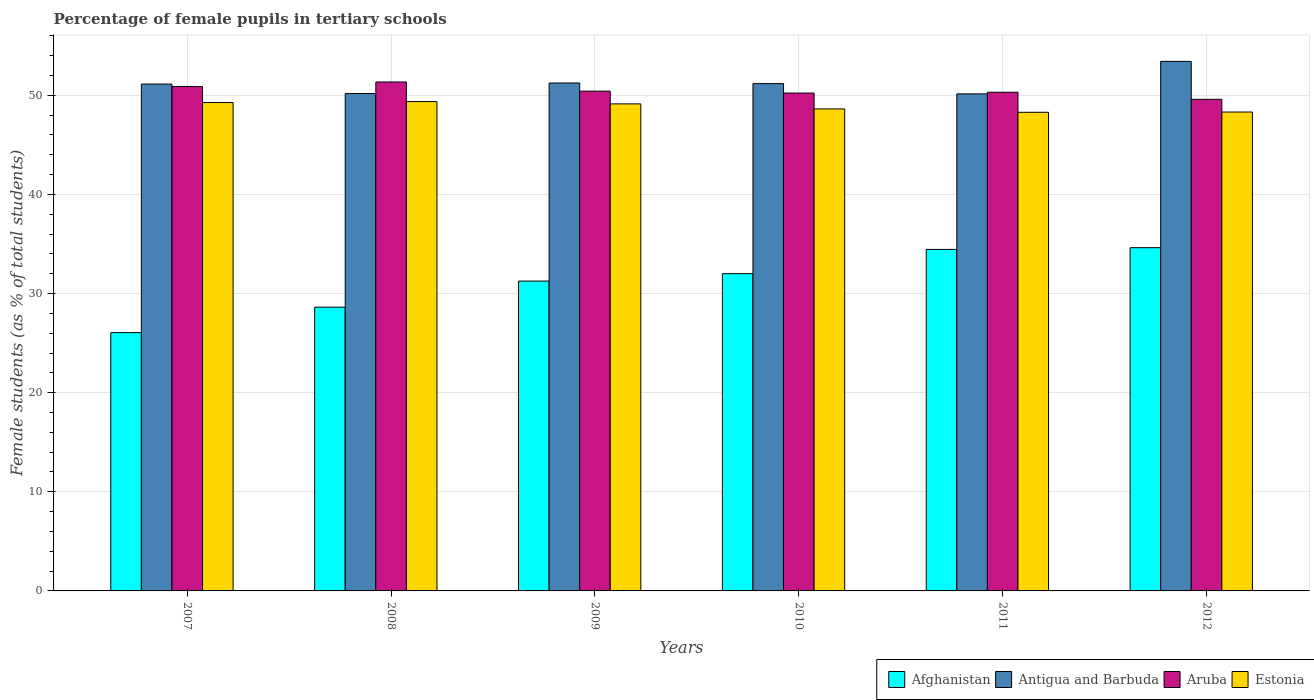How many groups of bars are there?
Offer a very short reply. 6. Are the number of bars per tick equal to the number of legend labels?
Ensure brevity in your answer.  Yes. How many bars are there on the 1st tick from the left?
Keep it short and to the point. 4. What is the percentage of female pupils in tertiary schools in Afghanistan in 2010?
Ensure brevity in your answer.  32.01. Across all years, what is the maximum percentage of female pupils in tertiary schools in Estonia?
Offer a terse response. 49.37. Across all years, what is the minimum percentage of female pupils in tertiary schools in Antigua and Barbuda?
Your answer should be compact. 50.15. In which year was the percentage of female pupils in tertiary schools in Aruba maximum?
Provide a succinct answer. 2008. What is the total percentage of female pupils in tertiary schools in Estonia in the graph?
Make the answer very short. 293.02. What is the difference between the percentage of female pupils in tertiary schools in Estonia in 2009 and that in 2012?
Offer a very short reply. 0.82. What is the difference between the percentage of female pupils in tertiary schools in Aruba in 2008 and the percentage of female pupils in tertiary schools in Afghanistan in 2012?
Provide a short and direct response. 16.72. What is the average percentage of female pupils in tertiary schools in Aruba per year?
Provide a succinct answer. 50.47. In the year 2011, what is the difference between the percentage of female pupils in tertiary schools in Antigua and Barbuda and percentage of female pupils in tertiary schools in Estonia?
Make the answer very short. 1.86. In how many years, is the percentage of female pupils in tertiary schools in Antigua and Barbuda greater than 40 %?
Your response must be concise. 6. What is the ratio of the percentage of female pupils in tertiary schools in Afghanistan in 2008 to that in 2011?
Your answer should be very brief. 0.83. Is the percentage of female pupils in tertiary schools in Antigua and Barbuda in 2007 less than that in 2012?
Offer a terse response. Yes. What is the difference between the highest and the second highest percentage of female pupils in tertiary schools in Estonia?
Provide a short and direct response. 0.1. What is the difference between the highest and the lowest percentage of female pupils in tertiary schools in Estonia?
Give a very brief answer. 1.08. Is the sum of the percentage of female pupils in tertiary schools in Estonia in 2009 and 2010 greater than the maximum percentage of female pupils in tertiary schools in Antigua and Barbuda across all years?
Your answer should be compact. Yes. What does the 4th bar from the left in 2009 represents?
Keep it short and to the point. Estonia. What does the 2nd bar from the right in 2010 represents?
Your response must be concise. Aruba. Is it the case that in every year, the sum of the percentage of female pupils in tertiary schools in Estonia and percentage of female pupils in tertiary schools in Antigua and Barbuda is greater than the percentage of female pupils in tertiary schools in Aruba?
Provide a succinct answer. Yes. How many years are there in the graph?
Your response must be concise. 6. What is the difference between two consecutive major ticks on the Y-axis?
Keep it short and to the point. 10. Does the graph contain any zero values?
Provide a short and direct response. No. Where does the legend appear in the graph?
Provide a short and direct response. Bottom right. What is the title of the graph?
Your answer should be compact. Percentage of female pupils in tertiary schools. What is the label or title of the Y-axis?
Ensure brevity in your answer.  Female students (as % of total students). What is the Female students (as % of total students) of Afghanistan in 2007?
Give a very brief answer. 26.06. What is the Female students (as % of total students) in Antigua and Barbuda in 2007?
Give a very brief answer. 51.14. What is the Female students (as % of total students) in Aruba in 2007?
Offer a very short reply. 50.89. What is the Female students (as % of total students) of Estonia in 2007?
Offer a terse response. 49.27. What is the Female students (as % of total students) of Afghanistan in 2008?
Give a very brief answer. 28.63. What is the Female students (as % of total students) in Antigua and Barbuda in 2008?
Your response must be concise. 50.19. What is the Female students (as % of total students) of Aruba in 2008?
Keep it short and to the point. 51.35. What is the Female students (as % of total students) of Estonia in 2008?
Provide a short and direct response. 49.37. What is the Female students (as % of total students) of Afghanistan in 2009?
Offer a terse response. 31.26. What is the Female students (as % of total students) in Antigua and Barbuda in 2009?
Ensure brevity in your answer.  51.24. What is the Female students (as % of total students) in Aruba in 2009?
Give a very brief answer. 50.42. What is the Female students (as % of total students) of Estonia in 2009?
Give a very brief answer. 49.14. What is the Female students (as % of total students) in Afghanistan in 2010?
Provide a short and direct response. 32.01. What is the Female students (as % of total students) of Antigua and Barbuda in 2010?
Ensure brevity in your answer.  51.19. What is the Female students (as % of total students) of Aruba in 2010?
Ensure brevity in your answer.  50.23. What is the Female students (as % of total students) of Estonia in 2010?
Provide a short and direct response. 48.63. What is the Female students (as % of total students) in Afghanistan in 2011?
Ensure brevity in your answer.  34.46. What is the Female students (as % of total students) of Antigua and Barbuda in 2011?
Your answer should be very brief. 50.15. What is the Female students (as % of total students) of Aruba in 2011?
Offer a terse response. 50.31. What is the Female students (as % of total students) of Estonia in 2011?
Ensure brevity in your answer.  48.29. What is the Female students (as % of total students) of Afghanistan in 2012?
Offer a very short reply. 34.63. What is the Female students (as % of total students) in Antigua and Barbuda in 2012?
Offer a very short reply. 53.43. What is the Female students (as % of total students) of Aruba in 2012?
Provide a succinct answer. 49.6. What is the Female students (as % of total students) in Estonia in 2012?
Your answer should be very brief. 48.32. Across all years, what is the maximum Female students (as % of total students) of Afghanistan?
Make the answer very short. 34.63. Across all years, what is the maximum Female students (as % of total students) in Antigua and Barbuda?
Make the answer very short. 53.43. Across all years, what is the maximum Female students (as % of total students) in Aruba?
Your answer should be compact. 51.35. Across all years, what is the maximum Female students (as % of total students) in Estonia?
Your response must be concise. 49.37. Across all years, what is the minimum Female students (as % of total students) of Afghanistan?
Your answer should be compact. 26.06. Across all years, what is the minimum Female students (as % of total students) in Antigua and Barbuda?
Your answer should be compact. 50.15. Across all years, what is the minimum Female students (as % of total students) in Aruba?
Offer a very short reply. 49.6. Across all years, what is the minimum Female students (as % of total students) in Estonia?
Keep it short and to the point. 48.29. What is the total Female students (as % of total students) in Afghanistan in the graph?
Make the answer very short. 187.05. What is the total Female students (as % of total students) of Antigua and Barbuda in the graph?
Make the answer very short. 307.33. What is the total Female students (as % of total students) in Aruba in the graph?
Your answer should be compact. 302.8. What is the total Female students (as % of total students) in Estonia in the graph?
Provide a succinct answer. 293.02. What is the difference between the Female students (as % of total students) of Afghanistan in 2007 and that in 2008?
Offer a very short reply. -2.57. What is the difference between the Female students (as % of total students) in Antigua and Barbuda in 2007 and that in 2008?
Give a very brief answer. 0.95. What is the difference between the Female students (as % of total students) in Aruba in 2007 and that in 2008?
Offer a very short reply. -0.46. What is the difference between the Female students (as % of total students) in Estonia in 2007 and that in 2008?
Your answer should be compact. -0.1. What is the difference between the Female students (as % of total students) of Afghanistan in 2007 and that in 2009?
Give a very brief answer. -5.2. What is the difference between the Female students (as % of total students) in Antigua and Barbuda in 2007 and that in 2009?
Your response must be concise. -0.11. What is the difference between the Female students (as % of total students) in Aruba in 2007 and that in 2009?
Your response must be concise. 0.46. What is the difference between the Female students (as % of total students) in Estonia in 2007 and that in 2009?
Keep it short and to the point. 0.14. What is the difference between the Female students (as % of total students) in Afghanistan in 2007 and that in 2010?
Your answer should be very brief. -5.95. What is the difference between the Female students (as % of total students) in Antigua and Barbuda in 2007 and that in 2010?
Ensure brevity in your answer.  -0.05. What is the difference between the Female students (as % of total students) of Aruba in 2007 and that in 2010?
Offer a terse response. 0.65. What is the difference between the Female students (as % of total students) in Estonia in 2007 and that in 2010?
Your answer should be very brief. 0.64. What is the difference between the Female students (as % of total students) in Afghanistan in 2007 and that in 2011?
Provide a short and direct response. -8.39. What is the difference between the Female students (as % of total students) in Antigua and Barbuda in 2007 and that in 2011?
Keep it short and to the point. 0.99. What is the difference between the Female students (as % of total students) in Aruba in 2007 and that in 2011?
Your answer should be very brief. 0.57. What is the difference between the Female students (as % of total students) in Estonia in 2007 and that in 2011?
Provide a succinct answer. 0.98. What is the difference between the Female students (as % of total students) in Afghanistan in 2007 and that in 2012?
Your response must be concise. -8.57. What is the difference between the Female students (as % of total students) of Antigua and Barbuda in 2007 and that in 2012?
Make the answer very short. -2.29. What is the difference between the Female students (as % of total students) of Aruba in 2007 and that in 2012?
Your answer should be compact. 1.28. What is the difference between the Female students (as % of total students) of Estonia in 2007 and that in 2012?
Provide a succinct answer. 0.96. What is the difference between the Female students (as % of total students) of Afghanistan in 2008 and that in 2009?
Your answer should be very brief. -2.63. What is the difference between the Female students (as % of total students) of Antigua and Barbuda in 2008 and that in 2009?
Provide a succinct answer. -1.06. What is the difference between the Female students (as % of total students) of Aruba in 2008 and that in 2009?
Your response must be concise. 0.92. What is the difference between the Female students (as % of total students) of Estonia in 2008 and that in 2009?
Your response must be concise. 0.23. What is the difference between the Female students (as % of total students) of Afghanistan in 2008 and that in 2010?
Offer a very short reply. -3.38. What is the difference between the Female students (as % of total students) of Aruba in 2008 and that in 2010?
Provide a short and direct response. 1.12. What is the difference between the Female students (as % of total students) in Estonia in 2008 and that in 2010?
Offer a terse response. 0.74. What is the difference between the Female students (as % of total students) in Afghanistan in 2008 and that in 2011?
Give a very brief answer. -5.83. What is the difference between the Female students (as % of total students) in Antigua and Barbuda in 2008 and that in 2011?
Make the answer very short. 0.04. What is the difference between the Female students (as % of total students) of Aruba in 2008 and that in 2011?
Provide a short and direct response. 1.04. What is the difference between the Female students (as % of total students) in Estonia in 2008 and that in 2011?
Your answer should be compact. 1.08. What is the difference between the Female students (as % of total students) in Afghanistan in 2008 and that in 2012?
Make the answer very short. -6. What is the difference between the Female students (as % of total students) in Antigua and Barbuda in 2008 and that in 2012?
Ensure brevity in your answer.  -3.24. What is the difference between the Female students (as % of total students) of Aruba in 2008 and that in 2012?
Provide a short and direct response. 1.75. What is the difference between the Female students (as % of total students) of Estonia in 2008 and that in 2012?
Ensure brevity in your answer.  1.05. What is the difference between the Female students (as % of total students) in Afghanistan in 2009 and that in 2010?
Offer a very short reply. -0.75. What is the difference between the Female students (as % of total students) in Antigua and Barbuda in 2009 and that in 2010?
Your answer should be compact. 0.06. What is the difference between the Female students (as % of total students) of Aruba in 2009 and that in 2010?
Provide a short and direct response. 0.19. What is the difference between the Female students (as % of total students) of Estonia in 2009 and that in 2010?
Your answer should be very brief. 0.51. What is the difference between the Female students (as % of total students) in Afghanistan in 2009 and that in 2011?
Offer a terse response. -3.2. What is the difference between the Female students (as % of total students) in Antigua and Barbuda in 2009 and that in 2011?
Make the answer very short. 1.1. What is the difference between the Female students (as % of total students) in Aruba in 2009 and that in 2011?
Offer a terse response. 0.11. What is the difference between the Female students (as % of total students) in Estonia in 2009 and that in 2011?
Provide a succinct answer. 0.85. What is the difference between the Female students (as % of total students) in Afghanistan in 2009 and that in 2012?
Keep it short and to the point. -3.37. What is the difference between the Female students (as % of total students) in Antigua and Barbuda in 2009 and that in 2012?
Offer a terse response. -2.19. What is the difference between the Female students (as % of total students) in Aruba in 2009 and that in 2012?
Offer a very short reply. 0.82. What is the difference between the Female students (as % of total students) of Estonia in 2009 and that in 2012?
Offer a terse response. 0.82. What is the difference between the Female students (as % of total students) of Afghanistan in 2010 and that in 2011?
Give a very brief answer. -2.45. What is the difference between the Female students (as % of total students) in Antigua and Barbuda in 2010 and that in 2011?
Ensure brevity in your answer.  1.04. What is the difference between the Female students (as % of total students) in Aruba in 2010 and that in 2011?
Your response must be concise. -0.08. What is the difference between the Female students (as % of total students) of Estonia in 2010 and that in 2011?
Provide a short and direct response. 0.34. What is the difference between the Female students (as % of total students) in Afghanistan in 2010 and that in 2012?
Ensure brevity in your answer.  -2.62. What is the difference between the Female students (as % of total students) of Antigua and Barbuda in 2010 and that in 2012?
Keep it short and to the point. -2.24. What is the difference between the Female students (as % of total students) in Aruba in 2010 and that in 2012?
Offer a terse response. 0.63. What is the difference between the Female students (as % of total students) in Estonia in 2010 and that in 2012?
Ensure brevity in your answer.  0.31. What is the difference between the Female students (as % of total students) of Afghanistan in 2011 and that in 2012?
Your answer should be very brief. -0.17. What is the difference between the Female students (as % of total students) in Antigua and Barbuda in 2011 and that in 2012?
Provide a succinct answer. -3.28. What is the difference between the Female students (as % of total students) in Aruba in 2011 and that in 2012?
Your answer should be compact. 0.71. What is the difference between the Female students (as % of total students) in Estonia in 2011 and that in 2012?
Provide a short and direct response. -0.03. What is the difference between the Female students (as % of total students) of Afghanistan in 2007 and the Female students (as % of total students) of Antigua and Barbuda in 2008?
Ensure brevity in your answer.  -24.12. What is the difference between the Female students (as % of total students) in Afghanistan in 2007 and the Female students (as % of total students) in Aruba in 2008?
Give a very brief answer. -25.29. What is the difference between the Female students (as % of total students) in Afghanistan in 2007 and the Female students (as % of total students) in Estonia in 2008?
Give a very brief answer. -23.31. What is the difference between the Female students (as % of total students) of Antigua and Barbuda in 2007 and the Female students (as % of total students) of Aruba in 2008?
Make the answer very short. -0.21. What is the difference between the Female students (as % of total students) of Antigua and Barbuda in 2007 and the Female students (as % of total students) of Estonia in 2008?
Your response must be concise. 1.76. What is the difference between the Female students (as % of total students) in Aruba in 2007 and the Female students (as % of total students) in Estonia in 2008?
Provide a succinct answer. 1.51. What is the difference between the Female students (as % of total students) in Afghanistan in 2007 and the Female students (as % of total students) in Antigua and Barbuda in 2009?
Offer a terse response. -25.18. What is the difference between the Female students (as % of total students) in Afghanistan in 2007 and the Female students (as % of total students) in Aruba in 2009?
Make the answer very short. -24.36. What is the difference between the Female students (as % of total students) in Afghanistan in 2007 and the Female students (as % of total students) in Estonia in 2009?
Keep it short and to the point. -23.08. What is the difference between the Female students (as % of total students) in Antigua and Barbuda in 2007 and the Female students (as % of total students) in Aruba in 2009?
Offer a terse response. 0.71. What is the difference between the Female students (as % of total students) in Antigua and Barbuda in 2007 and the Female students (as % of total students) in Estonia in 2009?
Offer a terse response. 2. What is the difference between the Female students (as % of total students) of Aruba in 2007 and the Female students (as % of total students) of Estonia in 2009?
Your response must be concise. 1.75. What is the difference between the Female students (as % of total students) of Afghanistan in 2007 and the Female students (as % of total students) of Antigua and Barbuda in 2010?
Your response must be concise. -25.12. What is the difference between the Female students (as % of total students) of Afghanistan in 2007 and the Female students (as % of total students) of Aruba in 2010?
Your answer should be compact. -24.17. What is the difference between the Female students (as % of total students) of Afghanistan in 2007 and the Female students (as % of total students) of Estonia in 2010?
Your answer should be very brief. -22.57. What is the difference between the Female students (as % of total students) in Antigua and Barbuda in 2007 and the Female students (as % of total students) in Aruba in 2010?
Your answer should be compact. 0.9. What is the difference between the Female students (as % of total students) in Antigua and Barbuda in 2007 and the Female students (as % of total students) in Estonia in 2010?
Provide a succinct answer. 2.51. What is the difference between the Female students (as % of total students) in Aruba in 2007 and the Female students (as % of total students) in Estonia in 2010?
Offer a very short reply. 2.26. What is the difference between the Female students (as % of total students) in Afghanistan in 2007 and the Female students (as % of total students) in Antigua and Barbuda in 2011?
Your answer should be very brief. -24.09. What is the difference between the Female students (as % of total students) of Afghanistan in 2007 and the Female students (as % of total students) of Aruba in 2011?
Offer a very short reply. -24.25. What is the difference between the Female students (as % of total students) of Afghanistan in 2007 and the Female students (as % of total students) of Estonia in 2011?
Give a very brief answer. -22.23. What is the difference between the Female students (as % of total students) in Antigua and Barbuda in 2007 and the Female students (as % of total students) in Aruba in 2011?
Give a very brief answer. 0.82. What is the difference between the Female students (as % of total students) in Antigua and Barbuda in 2007 and the Female students (as % of total students) in Estonia in 2011?
Ensure brevity in your answer.  2.84. What is the difference between the Female students (as % of total students) of Aruba in 2007 and the Female students (as % of total students) of Estonia in 2011?
Your answer should be compact. 2.59. What is the difference between the Female students (as % of total students) of Afghanistan in 2007 and the Female students (as % of total students) of Antigua and Barbuda in 2012?
Your answer should be very brief. -27.37. What is the difference between the Female students (as % of total students) in Afghanistan in 2007 and the Female students (as % of total students) in Aruba in 2012?
Provide a short and direct response. -23.54. What is the difference between the Female students (as % of total students) of Afghanistan in 2007 and the Female students (as % of total students) of Estonia in 2012?
Offer a very short reply. -22.26. What is the difference between the Female students (as % of total students) in Antigua and Barbuda in 2007 and the Female students (as % of total students) in Aruba in 2012?
Your answer should be very brief. 1.54. What is the difference between the Female students (as % of total students) of Antigua and Barbuda in 2007 and the Female students (as % of total students) of Estonia in 2012?
Make the answer very short. 2.82. What is the difference between the Female students (as % of total students) of Aruba in 2007 and the Female students (as % of total students) of Estonia in 2012?
Make the answer very short. 2.57. What is the difference between the Female students (as % of total students) of Afghanistan in 2008 and the Female students (as % of total students) of Antigua and Barbuda in 2009?
Offer a terse response. -22.61. What is the difference between the Female students (as % of total students) in Afghanistan in 2008 and the Female students (as % of total students) in Aruba in 2009?
Your answer should be compact. -21.79. What is the difference between the Female students (as % of total students) in Afghanistan in 2008 and the Female students (as % of total students) in Estonia in 2009?
Your response must be concise. -20.51. What is the difference between the Female students (as % of total students) of Antigua and Barbuda in 2008 and the Female students (as % of total students) of Aruba in 2009?
Offer a terse response. -0.24. What is the difference between the Female students (as % of total students) in Antigua and Barbuda in 2008 and the Female students (as % of total students) in Estonia in 2009?
Make the answer very short. 1.05. What is the difference between the Female students (as % of total students) of Aruba in 2008 and the Female students (as % of total students) of Estonia in 2009?
Make the answer very short. 2.21. What is the difference between the Female students (as % of total students) in Afghanistan in 2008 and the Female students (as % of total students) in Antigua and Barbuda in 2010?
Your answer should be compact. -22.55. What is the difference between the Female students (as % of total students) of Afghanistan in 2008 and the Female students (as % of total students) of Aruba in 2010?
Offer a terse response. -21.6. What is the difference between the Female students (as % of total students) in Afghanistan in 2008 and the Female students (as % of total students) in Estonia in 2010?
Offer a terse response. -20. What is the difference between the Female students (as % of total students) in Antigua and Barbuda in 2008 and the Female students (as % of total students) in Aruba in 2010?
Your answer should be compact. -0.05. What is the difference between the Female students (as % of total students) of Antigua and Barbuda in 2008 and the Female students (as % of total students) of Estonia in 2010?
Offer a very short reply. 1.56. What is the difference between the Female students (as % of total students) in Aruba in 2008 and the Female students (as % of total students) in Estonia in 2010?
Make the answer very short. 2.72. What is the difference between the Female students (as % of total students) in Afghanistan in 2008 and the Female students (as % of total students) in Antigua and Barbuda in 2011?
Provide a succinct answer. -21.52. What is the difference between the Female students (as % of total students) in Afghanistan in 2008 and the Female students (as % of total students) in Aruba in 2011?
Offer a terse response. -21.68. What is the difference between the Female students (as % of total students) of Afghanistan in 2008 and the Female students (as % of total students) of Estonia in 2011?
Provide a short and direct response. -19.66. What is the difference between the Female students (as % of total students) of Antigua and Barbuda in 2008 and the Female students (as % of total students) of Aruba in 2011?
Keep it short and to the point. -0.13. What is the difference between the Female students (as % of total students) in Antigua and Barbuda in 2008 and the Female students (as % of total students) in Estonia in 2011?
Make the answer very short. 1.89. What is the difference between the Female students (as % of total students) in Aruba in 2008 and the Female students (as % of total students) in Estonia in 2011?
Give a very brief answer. 3.06. What is the difference between the Female students (as % of total students) of Afghanistan in 2008 and the Female students (as % of total students) of Antigua and Barbuda in 2012?
Your answer should be compact. -24.8. What is the difference between the Female students (as % of total students) of Afghanistan in 2008 and the Female students (as % of total students) of Aruba in 2012?
Your answer should be compact. -20.97. What is the difference between the Female students (as % of total students) of Afghanistan in 2008 and the Female students (as % of total students) of Estonia in 2012?
Your answer should be compact. -19.69. What is the difference between the Female students (as % of total students) of Antigua and Barbuda in 2008 and the Female students (as % of total students) of Aruba in 2012?
Ensure brevity in your answer.  0.59. What is the difference between the Female students (as % of total students) of Antigua and Barbuda in 2008 and the Female students (as % of total students) of Estonia in 2012?
Keep it short and to the point. 1.87. What is the difference between the Female students (as % of total students) of Aruba in 2008 and the Female students (as % of total students) of Estonia in 2012?
Your answer should be compact. 3.03. What is the difference between the Female students (as % of total students) in Afghanistan in 2009 and the Female students (as % of total students) in Antigua and Barbuda in 2010?
Provide a succinct answer. -19.93. What is the difference between the Female students (as % of total students) of Afghanistan in 2009 and the Female students (as % of total students) of Aruba in 2010?
Provide a succinct answer. -18.97. What is the difference between the Female students (as % of total students) of Afghanistan in 2009 and the Female students (as % of total students) of Estonia in 2010?
Ensure brevity in your answer.  -17.37. What is the difference between the Female students (as % of total students) of Antigua and Barbuda in 2009 and the Female students (as % of total students) of Aruba in 2010?
Offer a very short reply. 1.01. What is the difference between the Female students (as % of total students) of Antigua and Barbuda in 2009 and the Female students (as % of total students) of Estonia in 2010?
Your response must be concise. 2.62. What is the difference between the Female students (as % of total students) of Aruba in 2009 and the Female students (as % of total students) of Estonia in 2010?
Give a very brief answer. 1.79. What is the difference between the Female students (as % of total students) in Afghanistan in 2009 and the Female students (as % of total students) in Antigua and Barbuda in 2011?
Your answer should be compact. -18.89. What is the difference between the Female students (as % of total students) in Afghanistan in 2009 and the Female students (as % of total students) in Aruba in 2011?
Your answer should be compact. -19.05. What is the difference between the Female students (as % of total students) of Afghanistan in 2009 and the Female students (as % of total students) of Estonia in 2011?
Your answer should be very brief. -17.03. What is the difference between the Female students (as % of total students) in Antigua and Barbuda in 2009 and the Female students (as % of total students) in Aruba in 2011?
Make the answer very short. 0.93. What is the difference between the Female students (as % of total students) of Antigua and Barbuda in 2009 and the Female students (as % of total students) of Estonia in 2011?
Make the answer very short. 2.95. What is the difference between the Female students (as % of total students) in Aruba in 2009 and the Female students (as % of total students) in Estonia in 2011?
Provide a succinct answer. 2.13. What is the difference between the Female students (as % of total students) in Afghanistan in 2009 and the Female students (as % of total students) in Antigua and Barbuda in 2012?
Give a very brief answer. -22.17. What is the difference between the Female students (as % of total students) of Afghanistan in 2009 and the Female students (as % of total students) of Aruba in 2012?
Make the answer very short. -18.34. What is the difference between the Female students (as % of total students) in Afghanistan in 2009 and the Female students (as % of total students) in Estonia in 2012?
Offer a terse response. -17.06. What is the difference between the Female students (as % of total students) in Antigua and Barbuda in 2009 and the Female students (as % of total students) in Aruba in 2012?
Your answer should be compact. 1.64. What is the difference between the Female students (as % of total students) of Antigua and Barbuda in 2009 and the Female students (as % of total students) of Estonia in 2012?
Your response must be concise. 2.93. What is the difference between the Female students (as % of total students) of Aruba in 2009 and the Female students (as % of total students) of Estonia in 2012?
Ensure brevity in your answer.  2.11. What is the difference between the Female students (as % of total students) of Afghanistan in 2010 and the Female students (as % of total students) of Antigua and Barbuda in 2011?
Offer a terse response. -18.14. What is the difference between the Female students (as % of total students) in Afghanistan in 2010 and the Female students (as % of total students) in Aruba in 2011?
Your answer should be very brief. -18.3. What is the difference between the Female students (as % of total students) of Afghanistan in 2010 and the Female students (as % of total students) of Estonia in 2011?
Your answer should be compact. -16.28. What is the difference between the Female students (as % of total students) in Antigua and Barbuda in 2010 and the Female students (as % of total students) in Aruba in 2011?
Provide a succinct answer. 0.87. What is the difference between the Female students (as % of total students) in Antigua and Barbuda in 2010 and the Female students (as % of total students) in Estonia in 2011?
Offer a very short reply. 2.89. What is the difference between the Female students (as % of total students) in Aruba in 2010 and the Female students (as % of total students) in Estonia in 2011?
Your answer should be compact. 1.94. What is the difference between the Female students (as % of total students) of Afghanistan in 2010 and the Female students (as % of total students) of Antigua and Barbuda in 2012?
Give a very brief answer. -21.42. What is the difference between the Female students (as % of total students) of Afghanistan in 2010 and the Female students (as % of total students) of Aruba in 2012?
Your answer should be very brief. -17.59. What is the difference between the Female students (as % of total students) of Afghanistan in 2010 and the Female students (as % of total students) of Estonia in 2012?
Offer a very short reply. -16.31. What is the difference between the Female students (as % of total students) of Antigua and Barbuda in 2010 and the Female students (as % of total students) of Aruba in 2012?
Your answer should be very brief. 1.59. What is the difference between the Female students (as % of total students) of Antigua and Barbuda in 2010 and the Female students (as % of total students) of Estonia in 2012?
Ensure brevity in your answer.  2.87. What is the difference between the Female students (as % of total students) of Aruba in 2010 and the Female students (as % of total students) of Estonia in 2012?
Offer a terse response. 1.91. What is the difference between the Female students (as % of total students) in Afghanistan in 2011 and the Female students (as % of total students) in Antigua and Barbuda in 2012?
Offer a terse response. -18.97. What is the difference between the Female students (as % of total students) of Afghanistan in 2011 and the Female students (as % of total students) of Aruba in 2012?
Give a very brief answer. -15.14. What is the difference between the Female students (as % of total students) of Afghanistan in 2011 and the Female students (as % of total students) of Estonia in 2012?
Your answer should be compact. -13.86. What is the difference between the Female students (as % of total students) in Antigua and Barbuda in 2011 and the Female students (as % of total students) in Aruba in 2012?
Make the answer very short. 0.55. What is the difference between the Female students (as % of total students) in Antigua and Barbuda in 2011 and the Female students (as % of total students) in Estonia in 2012?
Offer a very short reply. 1.83. What is the difference between the Female students (as % of total students) of Aruba in 2011 and the Female students (as % of total students) of Estonia in 2012?
Keep it short and to the point. 1.99. What is the average Female students (as % of total students) of Afghanistan per year?
Provide a short and direct response. 31.17. What is the average Female students (as % of total students) in Antigua and Barbuda per year?
Provide a short and direct response. 51.22. What is the average Female students (as % of total students) of Aruba per year?
Offer a terse response. 50.47. What is the average Female students (as % of total students) in Estonia per year?
Keep it short and to the point. 48.84. In the year 2007, what is the difference between the Female students (as % of total students) in Afghanistan and Female students (as % of total students) in Antigua and Barbuda?
Your answer should be very brief. -25.07. In the year 2007, what is the difference between the Female students (as % of total students) of Afghanistan and Female students (as % of total students) of Aruba?
Provide a succinct answer. -24.82. In the year 2007, what is the difference between the Female students (as % of total students) in Afghanistan and Female students (as % of total students) in Estonia?
Ensure brevity in your answer.  -23.21. In the year 2007, what is the difference between the Female students (as % of total students) in Antigua and Barbuda and Female students (as % of total students) in Aruba?
Make the answer very short. 0.25. In the year 2007, what is the difference between the Female students (as % of total students) of Antigua and Barbuda and Female students (as % of total students) of Estonia?
Make the answer very short. 1.86. In the year 2007, what is the difference between the Female students (as % of total students) in Aruba and Female students (as % of total students) in Estonia?
Ensure brevity in your answer.  1.61. In the year 2008, what is the difference between the Female students (as % of total students) of Afghanistan and Female students (as % of total students) of Antigua and Barbuda?
Your response must be concise. -21.55. In the year 2008, what is the difference between the Female students (as % of total students) in Afghanistan and Female students (as % of total students) in Aruba?
Ensure brevity in your answer.  -22.72. In the year 2008, what is the difference between the Female students (as % of total students) in Afghanistan and Female students (as % of total students) in Estonia?
Give a very brief answer. -20.74. In the year 2008, what is the difference between the Female students (as % of total students) in Antigua and Barbuda and Female students (as % of total students) in Aruba?
Provide a short and direct response. -1.16. In the year 2008, what is the difference between the Female students (as % of total students) of Antigua and Barbuda and Female students (as % of total students) of Estonia?
Offer a very short reply. 0.81. In the year 2008, what is the difference between the Female students (as % of total students) in Aruba and Female students (as % of total students) in Estonia?
Keep it short and to the point. 1.98. In the year 2009, what is the difference between the Female students (as % of total students) in Afghanistan and Female students (as % of total students) in Antigua and Barbuda?
Ensure brevity in your answer.  -19.98. In the year 2009, what is the difference between the Female students (as % of total students) of Afghanistan and Female students (as % of total students) of Aruba?
Give a very brief answer. -19.16. In the year 2009, what is the difference between the Female students (as % of total students) of Afghanistan and Female students (as % of total students) of Estonia?
Give a very brief answer. -17.88. In the year 2009, what is the difference between the Female students (as % of total students) of Antigua and Barbuda and Female students (as % of total students) of Aruba?
Keep it short and to the point. 0.82. In the year 2009, what is the difference between the Female students (as % of total students) in Antigua and Barbuda and Female students (as % of total students) in Estonia?
Your response must be concise. 2.11. In the year 2009, what is the difference between the Female students (as % of total students) in Aruba and Female students (as % of total students) in Estonia?
Offer a very short reply. 1.28. In the year 2010, what is the difference between the Female students (as % of total students) of Afghanistan and Female students (as % of total students) of Antigua and Barbuda?
Your answer should be very brief. -19.18. In the year 2010, what is the difference between the Female students (as % of total students) of Afghanistan and Female students (as % of total students) of Aruba?
Keep it short and to the point. -18.22. In the year 2010, what is the difference between the Female students (as % of total students) of Afghanistan and Female students (as % of total students) of Estonia?
Offer a terse response. -16.62. In the year 2010, what is the difference between the Female students (as % of total students) of Antigua and Barbuda and Female students (as % of total students) of Aruba?
Your answer should be compact. 0.95. In the year 2010, what is the difference between the Female students (as % of total students) in Antigua and Barbuda and Female students (as % of total students) in Estonia?
Make the answer very short. 2.56. In the year 2010, what is the difference between the Female students (as % of total students) of Aruba and Female students (as % of total students) of Estonia?
Give a very brief answer. 1.6. In the year 2011, what is the difference between the Female students (as % of total students) in Afghanistan and Female students (as % of total students) in Antigua and Barbuda?
Ensure brevity in your answer.  -15.69. In the year 2011, what is the difference between the Female students (as % of total students) of Afghanistan and Female students (as % of total students) of Aruba?
Keep it short and to the point. -15.86. In the year 2011, what is the difference between the Female students (as % of total students) in Afghanistan and Female students (as % of total students) in Estonia?
Give a very brief answer. -13.83. In the year 2011, what is the difference between the Female students (as % of total students) of Antigua and Barbuda and Female students (as % of total students) of Aruba?
Ensure brevity in your answer.  -0.16. In the year 2011, what is the difference between the Female students (as % of total students) of Antigua and Barbuda and Female students (as % of total students) of Estonia?
Offer a very short reply. 1.86. In the year 2011, what is the difference between the Female students (as % of total students) of Aruba and Female students (as % of total students) of Estonia?
Offer a very short reply. 2.02. In the year 2012, what is the difference between the Female students (as % of total students) in Afghanistan and Female students (as % of total students) in Antigua and Barbuda?
Offer a very short reply. -18.8. In the year 2012, what is the difference between the Female students (as % of total students) in Afghanistan and Female students (as % of total students) in Aruba?
Your answer should be very brief. -14.97. In the year 2012, what is the difference between the Female students (as % of total students) in Afghanistan and Female students (as % of total students) in Estonia?
Give a very brief answer. -13.69. In the year 2012, what is the difference between the Female students (as % of total students) of Antigua and Barbuda and Female students (as % of total students) of Aruba?
Your response must be concise. 3.83. In the year 2012, what is the difference between the Female students (as % of total students) of Antigua and Barbuda and Female students (as % of total students) of Estonia?
Make the answer very short. 5.11. In the year 2012, what is the difference between the Female students (as % of total students) in Aruba and Female students (as % of total students) in Estonia?
Your answer should be compact. 1.28. What is the ratio of the Female students (as % of total students) of Afghanistan in 2007 to that in 2008?
Your answer should be compact. 0.91. What is the ratio of the Female students (as % of total students) of Antigua and Barbuda in 2007 to that in 2008?
Provide a succinct answer. 1.02. What is the ratio of the Female students (as % of total students) of Estonia in 2007 to that in 2008?
Give a very brief answer. 1. What is the ratio of the Female students (as % of total students) in Afghanistan in 2007 to that in 2009?
Make the answer very short. 0.83. What is the ratio of the Female students (as % of total students) of Aruba in 2007 to that in 2009?
Provide a succinct answer. 1.01. What is the ratio of the Female students (as % of total students) of Estonia in 2007 to that in 2009?
Provide a short and direct response. 1. What is the ratio of the Female students (as % of total students) in Afghanistan in 2007 to that in 2010?
Offer a terse response. 0.81. What is the ratio of the Female students (as % of total students) in Antigua and Barbuda in 2007 to that in 2010?
Ensure brevity in your answer.  1. What is the ratio of the Female students (as % of total students) in Estonia in 2007 to that in 2010?
Provide a succinct answer. 1.01. What is the ratio of the Female students (as % of total students) in Afghanistan in 2007 to that in 2011?
Ensure brevity in your answer.  0.76. What is the ratio of the Female students (as % of total students) in Antigua and Barbuda in 2007 to that in 2011?
Offer a very short reply. 1.02. What is the ratio of the Female students (as % of total students) in Aruba in 2007 to that in 2011?
Keep it short and to the point. 1.01. What is the ratio of the Female students (as % of total students) of Estonia in 2007 to that in 2011?
Keep it short and to the point. 1.02. What is the ratio of the Female students (as % of total students) of Afghanistan in 2007 to that in 2012?
Provide a short and direct response. 0.75. What is the ratio of the Female students (as % of total students) of Antigua and Barbuda in 2007 to that in 2012?
Ensure brevity in your answer.  0.96. What is the ratio of the Female students (as % of total students) of Aruba in 2007 to that in 2012?
Your response must be concise. 1.03. What is the ratio of the Female students (as % of total students) of Estonia in 2007 to that in 2012?
Provide a succinct answer. 1.02. What is the ratio of the Female students (as % of total students) of Afghanistan in 2008 to that in 2009?
Offer a very short reply. 0.92. What is the ratio of the Female students (as % of total students) in Antigua and Barbuda in 2008 to that in 2009?
Your response must be concise. 0.98. What is the ratio of the Female students (as % of total students) in Aruba in 2008 to that in 2009?
Provide a short and direct response. 1.02. What is the ratio of the Female students (as % of total students) of Afghanistan in 2008 to that in 2010?
Keep it short and to the point. 0.89. What is the ratio of the Female students (as % of total students) in Antigua and Barbuda in 2008 to that in 2010?
Offer a very short reply. 0.98. What is the ratio of the Female students (as % of total students) in Aruba in 2008 to that in 2010?
Your answer should be very brief. 1.02. What is the ratio of the Female students (as % of total students) in Estonia in 2008 to that in 2010?
Provide a succinct answer. 1.02. What is the ratio of the Female students (as % of total students) of Afghanistan in 2008 to that in 2011?
Your answer should be compact. 0.83. What is the ratio of the Female students (as % of total students) of Aruba in 2008 to that in 2011?
Provide a short and direct response. 1.02. What is the ratio of the Female students (as % of total students) in Estonia in 2008 to that in 2011?
Provide a succinct answer. 1.02. What is the ratio of the Female students (as % of total students) of Afghanistan in 2008 to that in 2012?
Your response must be concise. 0.83. What is the ratio of the Female students (as % of total students) of Antigua and Barbuda in 2008 to that in 2012?
Keep it short and to the point. 0.94. What is the ratio of the Female students (as % of total students) of Aruba in 2008 to that in 2012?
Ensure brevity in your answer.  1.04. What is the ratio of the Female students (as % of total students) in Estonia in 2008 to that in 2012?
Provide a short and direct response. 1.02. What is the ratio of the Female students (as % of total students) in Afghanistan in 2009 to that in 2010?
Your answer should be very brief. 0.98. What is the ratio of the Female students (as % of total students) of Antigua and Barbuda in 2009 to that in 2010?
Your response must be concise. 1. What is the ratio of the Female students (as % of total students) in Estonia in 2009 to that in 2010?
Offer a terse response. 1.01. What is the ratio of the Female students (as % of total students) of Afghanistan in 2009 to that in 2011?
Provide a short and direct response. 0.91. What is the ratio of the Female students (as % of total students) in Antigua and Barbuda in 2009 to that in 2011?
Offer a very short reply. 1.02. What is the ratio of the Female students (as % of total students) in Aruba in 2009 to that in 2011?
Give a very brief answer. 1. What is the ratio of the Female students (as % of total students) of Estonia in 2009 to that in 2011?
Keep it short and to the point. 1.02. What is the ratio of the Female students (as % of total students) of Afghanistan in 2009 to that in 2012?
Provide a short and direct response. 0.9. What is the ratio of the Female students (as % of total students) in Antigua and Barbuda in 2009 to that in 2012?
Keep it short and to the point. 0.96. What is the ratio of the Female students (as % of total students) of Aruba in 2009 to that in 2012?
Your answer should be very brief. 1.02. What is the ratio of the Female students (as % of total students) of Estonia in 2009 to that in 2012?
Your answer should be compact. 1.02. What is the ratio of the Female students (as % of total students) in Afghanistan in 2010 to that in 2011?
Offer a very short reply. 0.93. What is the ratio of the Female students (as % of total students) of Antigua and Barbuda in 2010 to that in 2011?
Provide a succinct answer. 1.02. What is the ratio of the Female students (as % of total students) of Aruba in 2010 to that in 2011?
Offer a terse response. 1. What is the ratio of the Female students (as % of total students) in Estonia in 2010 to that in 2011?
Your answer should be very brief. 1.01. What is the ratio of the Female students (as % of total students) of Afghanistan in 2010 to that in 2012?
Your response must be concise. 0.92. What is the ratio of the Female students (as % of total students) in Antigua and Barbuda in 2010 to that in 2012?
Offer a very short reply. 0.96. What is the ratio of the Female students (as % of total students) of Aruba in 2010 to that in 2012?
Offer a very short reply. 1.01. What is the ratio of the Female students (as % of total students) of Antigua and Barbuda in 2011 to that in 2012?
Your response must be concise. 0.94. What is the ratio of the Female students (as % of total students) of Aruba in 2011 to that in 2012?
Your response must be concise. 1.01. What is the difference between the highest and the second highest Female students (as % of total students) in Afghanistan?
Provide a short and direct response. 0.17. What is the difference between the highest and the second highest Female students (as % of total students) of Antigua and Barbuda?
Your answer should be compact. 2.19. What is the difference between the highest and the second highest Female students (as % of total students) in Aruba?
Ensure brevity in your answer.  0.46. What is the difference between the highest and the second highest Female students (as % of total students) of Estonia?
Offer a terse response. 0.1. What is the difference between the highest and the lowest Female students (as % of total students) of Afghanistan?
Your answer should be compact. 8.57. What is the difference between the highest and the lowest Female students (as % of total students) in Antigua and Barbuda?
Offer a very short reply. 3.28. What is the difference between the highest and the lowest Female students (as % of total students) of Aruba?
Your answer should be very brief. 1.75. What is the difference between the highest and the lowest Female students (as % of total students) in Estonia?
Offer a very short reply. 1.08. 